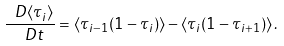Convert formula to latex. <formula><loc_0><loc_0><loc_500><loc_500>\frac { \ D \langle \tau _ { i } \rangle } { \ D t } = \langle \tau _ { i - 1 } ( 1 - \tau _ { i } ) \rangle - \langle \tau _ { i } ( 1 - \tau _ { i + 1 } ) \rangle \, .</formula> 